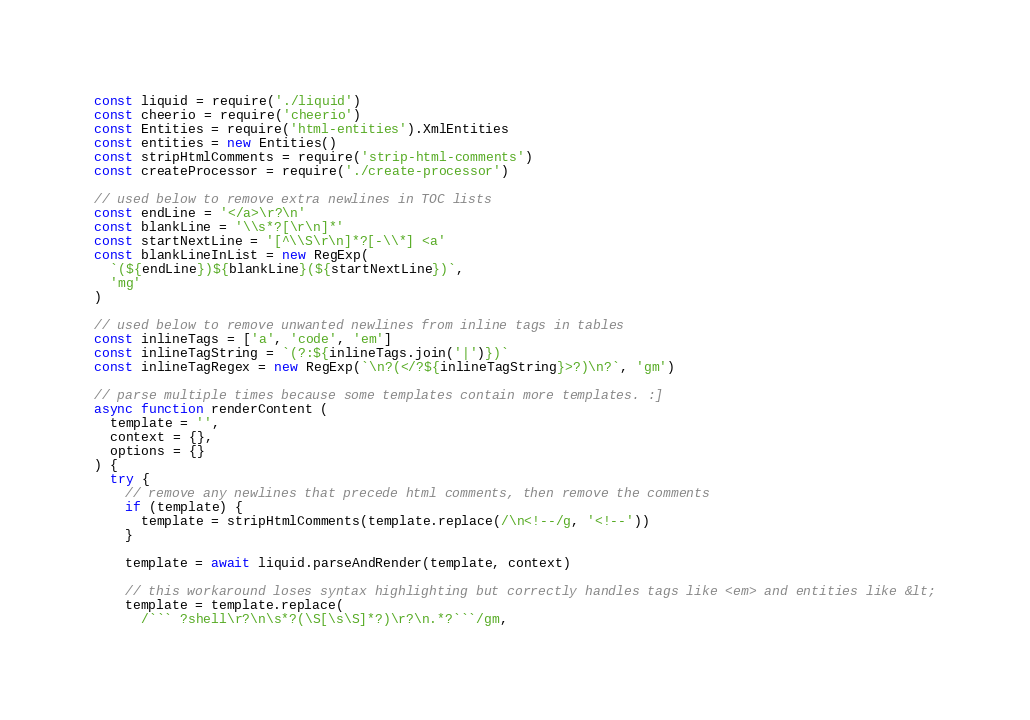Convert code to text. <code><loc_0><loc_0><loc_500><loc_500><_JavaScript_>const liquid = require('./liquid')
const cheerio = require('cheerio')
const Entities = require('html-entities').XmlEntities
const entities = new Entities()
const stripHtmlComments = require('strip-html-comments')
const createProcessor = require('./create-processor')

// used below to remove extra newlines in TOC lists
const endLine = '</a>\r?\n'
const blankLine = '\\s*?[\r\n]*'
const startNextLine = '[^\\S\r\n]*?[-\\*] <a'
const blankLineInList = new RegExp(
  `(${endLine})${blankLine}(${startNextLine})`,
  'mg'
)

// used below to remove unwanted newlines from inline tags in tables
const inlineTags = ['a', 'code', 'em']
const inlineTagString = `(?:${inlineTags.join('|')})`
const inlineTagRegex = new RegExp(`\n?(</?${inlineTagString}>?)\n?`, 'gm')

// parse multiple times because some templates contain more templates. :]
async function renderContent (
  template = '',
  context = {},
  options = {}
) {
  try {
    // remove any newlines that precede html comments, then remove the comments
    if (template) {
      template = stripHtmlComments(template.replace(/\n<!--/g, '<!--'))
    }

    template = await liquid.parseAndRender(template, context)

    // this workaround loses syntax highlighting but correctly handles tags like <em> and entities like &lt;
    template = template.replace(
      /``` ?shell\r?\n\s*?(\S[\s\S]*?)\r?\n.*?```/gm,</code> 